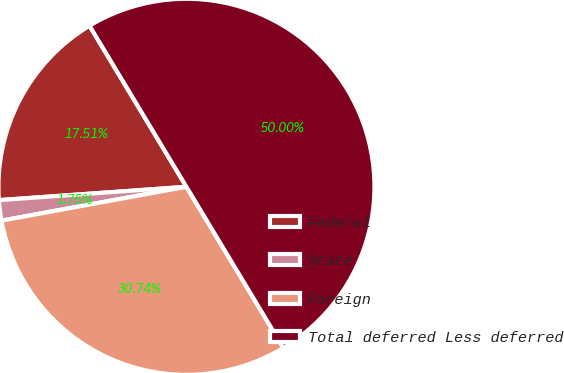Convert chart to OTSL. <chart><loc_0><loc_0><loc_500><loc_500><pie_chart><fcel>Federal<fcel>State<fcel>Foreign<fcel>Total deferred Less deferred<nl><fcel>17.51%<fcel>1.75%<fcel>30.74%<fcel>50.0%<nl></chart> 